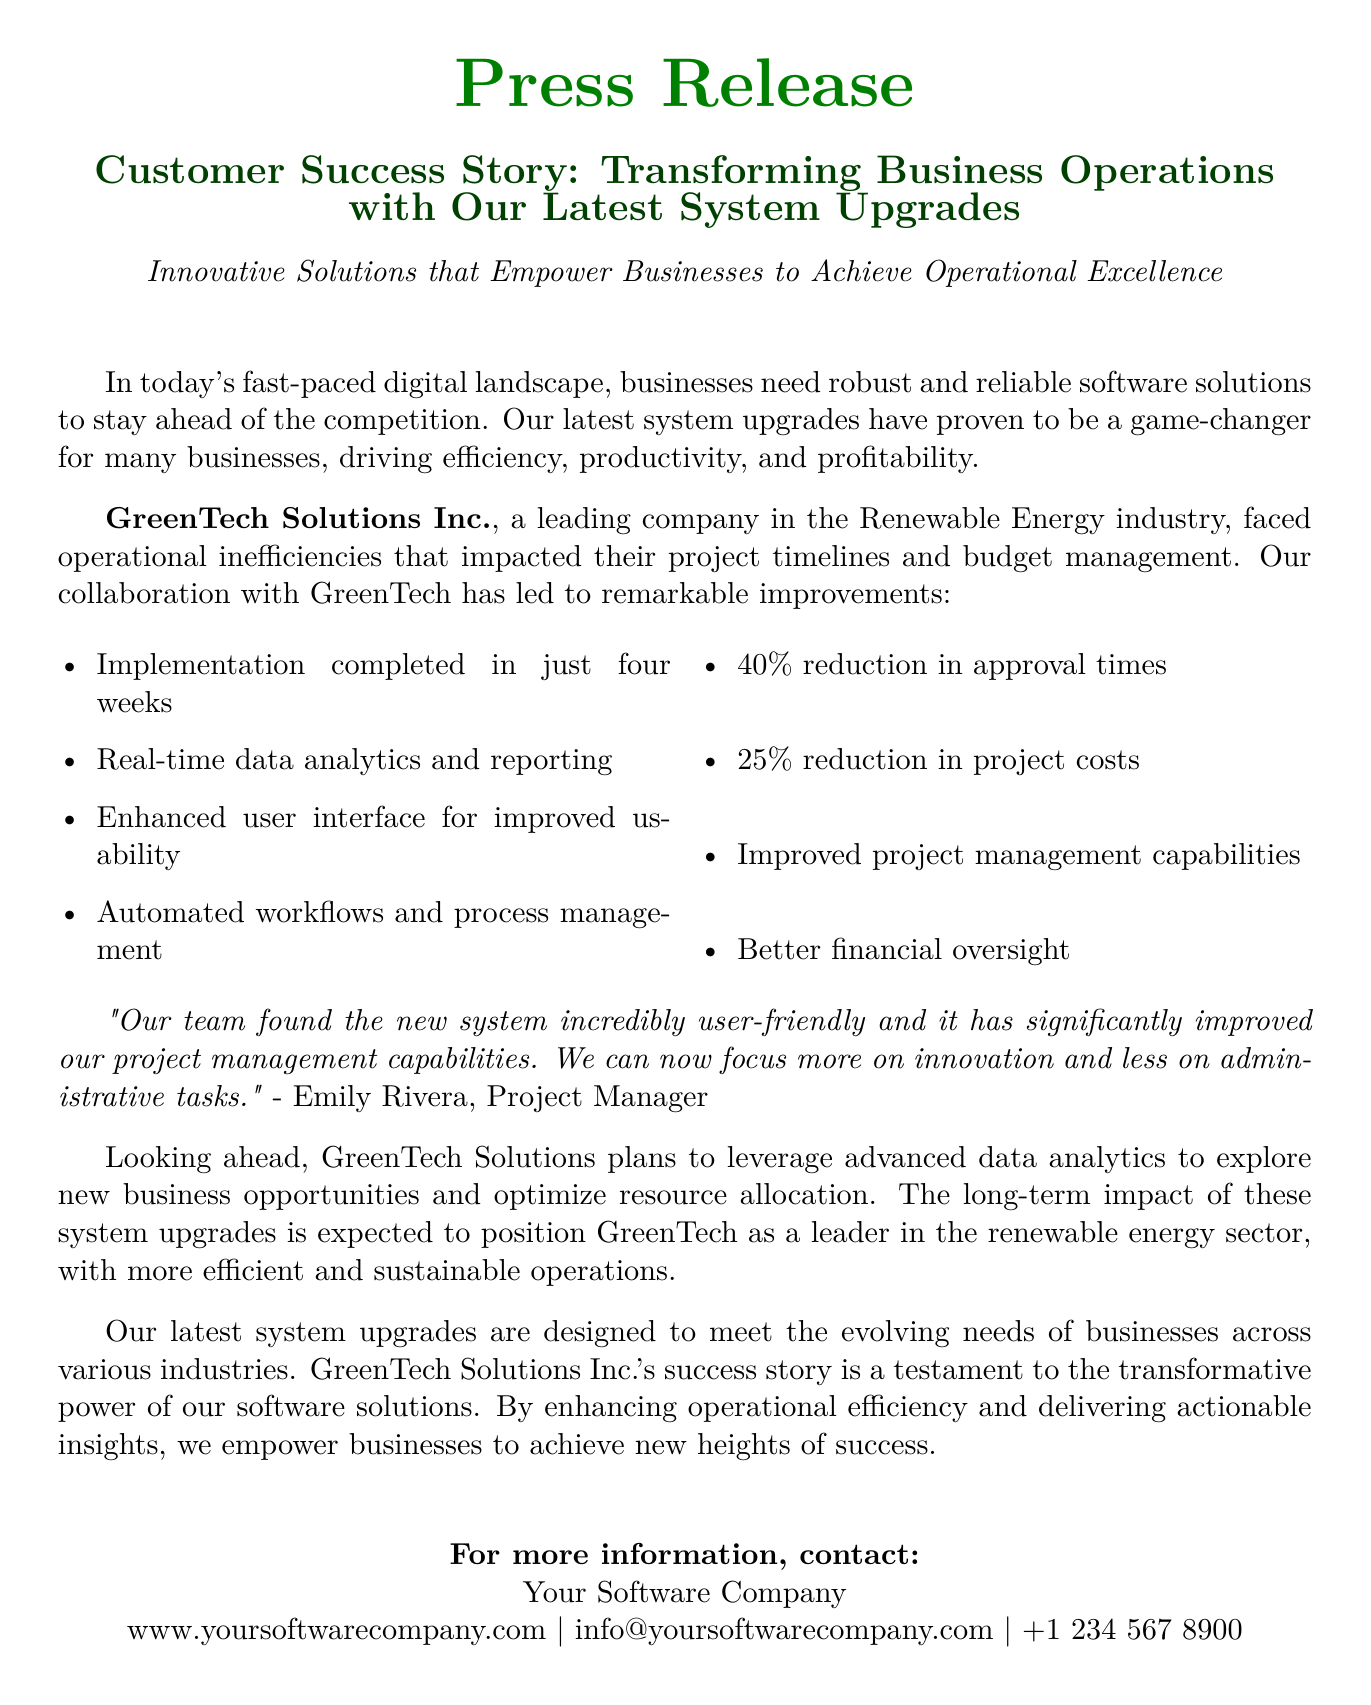what is the name of the company featured in the success story? The company highlighted in the success story is GreenTech Solutions Inc.
Answer: GreenTech Solutions Inc how long did the implementation take? The document states that the implementation was completed in just four weeks.
Answer: four weeks what percentage reduction in approval times was achieved? According to the document, there was a 40% reduction in approval times.
Answer: 40% who is quoted in the document? The quote in the document is from Emily Rivera, who is identified as a Project Manager.
Answer: Emily Rivera what is the expected long-term impact of the system upgrades for GreenTech Solutions? The document mentions that the long-term impact is expected to position GreenTech as a leader in the renewable energy sector.
Answer: leader in the renewable energy sector what type of business sector does GreenTech Solutions operate in? The document indicates that GreenTech Solutions operates in the Renewable Energy industry.
Answer: Renewable Energy what improvements were noted in project management capabilities? The document highlights improved project management capabilities as one of the benefits of the system upgrades.
Answer: improved project management capabilities 